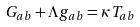<formula> <loc_0><loc_0><loc_500><loc_500>G _ { a b } + \Lambda g _ { a b } = \kappa T _ { a b }</formula> 